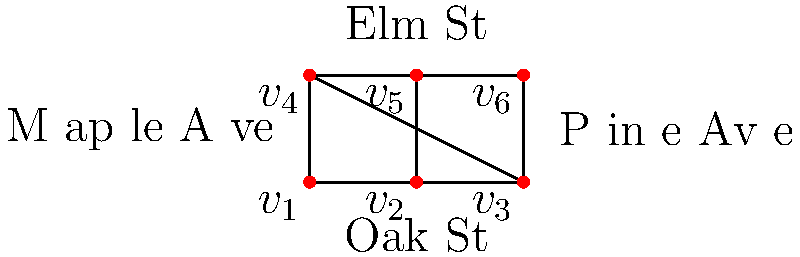As a member of the neighborhood watch team, you need to plan the most efficient route to patrol all streets in the Cantu family's neighborhood. The streets are represented by edges in the graph, and intersections by vertices. What is the minimum number of times you need to traverse any street to cover all streets exactly once, starting and ending at the same point? To solve this problem, we can use the concept of Eulerian circuits in graph theory. Here's a step-by-step approach:

1. First, we need to determine if the graph has an Eulerian circuit. For a graph to have an Eulerian circuit:
   - All vertices must have an even degree (number of edges connected to it).
   - The graph must be connected.

2. Let's check the degree of each vertex:
   - $v_1$: degree 3
   - $v_2$: degree 4
   - $v_3$: degree 3
   - $v_4$: degree 3
   - $v_5$: degree 4
   - $v_6$: degree 3

3. We can see that all vertices have odd degrees except $v_2$ and $v_5$. This means the graph does not have an Eulerian circuit.

4. When a graph doesn't have an Eulerian circuit, we need to find the minimum number of edge repetitions to create a circuit that covers all edges.

5. The number of odd-degree vertices in a graph is always even. In this case, we have 4 odd-degree vertices.

6. The minimum number of edge repetitions needed is half the number of odd-degree vertices. So, in this case:

   $\text{Minimum repetitions} = \frac{\text{Number of odd-degree vertices}}{2} = \frac{4}{2} = 2$

7. This means you need to traverse 2 streets twice to create a route that covers all streets and returns to the starting point.
Answer: 2 streets 